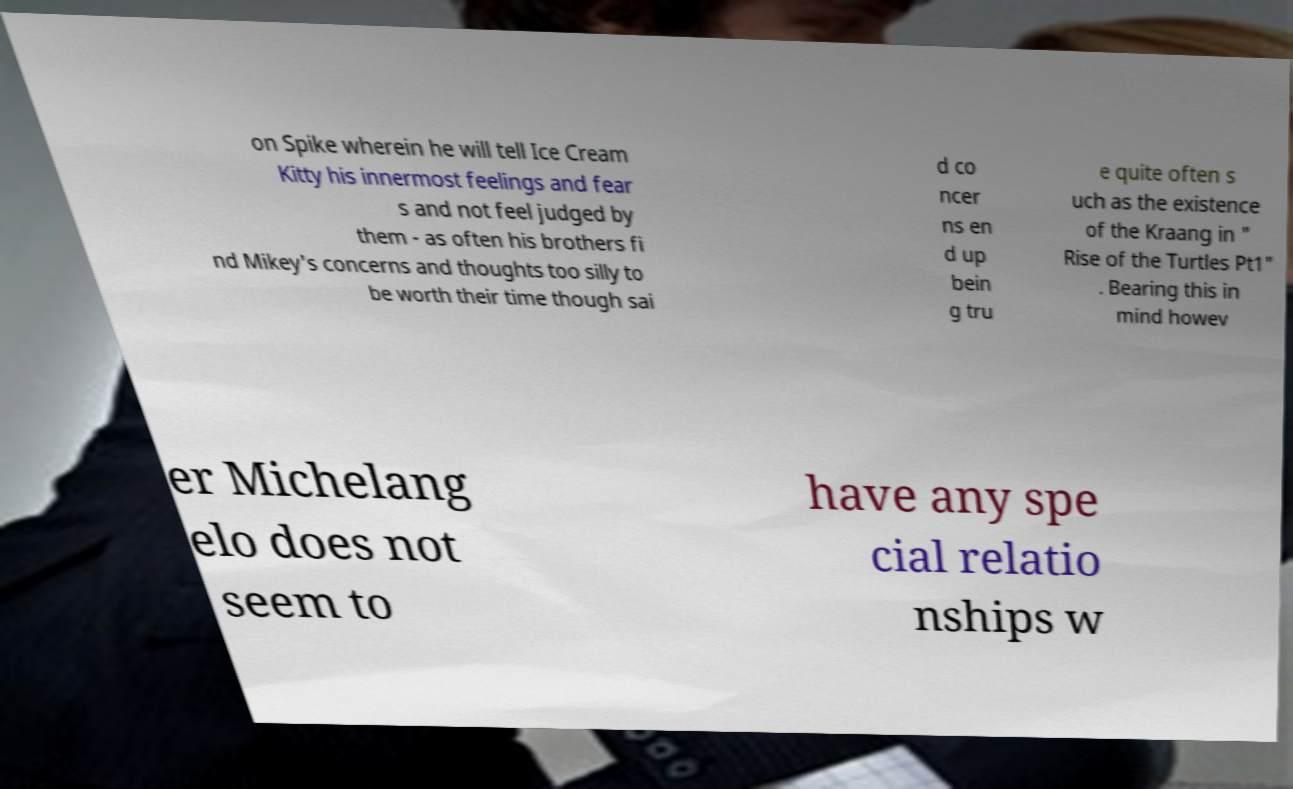There's text embedded in this image that I need extracted. Can you transcribe it verbatim? on Spike wherein he will tell Ice Cream Kitty his innermost feelings and fear s and not feel judged by them - as often his brothers fi nd Mikey's concerns and thoughts too silly to be worth their time though sai d co ncer ns en d up bein g tru e quite often s uch as the existence of the Kraang in " Rise of the Turtles Pt1" . Bearing this in mind howev er Michelang elo does not seem to have any spe cial relatio nships w 